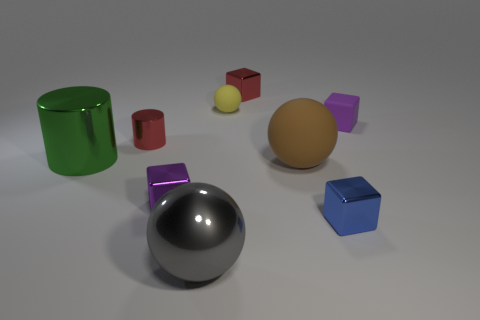Add 1 red metal balls. How many objects exist? 10 Subtract all cylinders. How many objects are left? 7 Add 5 large things. How many large things exist? 8 Subtract 2 purple blocks. How many objects are left? 7 Subtract all large green cylinders. Subtract all tiny rubber cylinders. How many objects are left? 8 Add 1 tiny rubber balls. How many tiny rubber balls are left? 2 